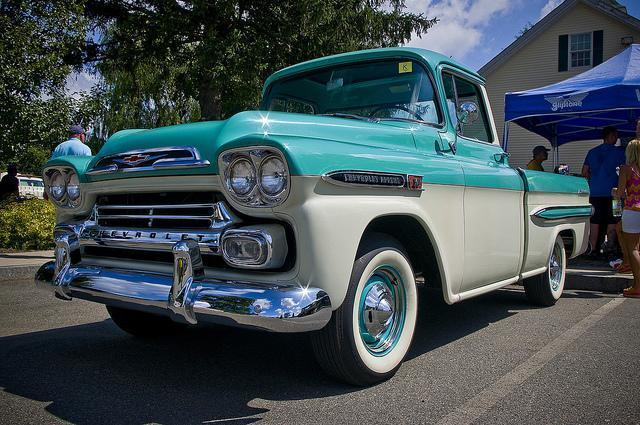How many people are in the photo?
Give a very brief answer. 2. How many cupcakes have an elephant on them?
Give a very brief answer. 0. 